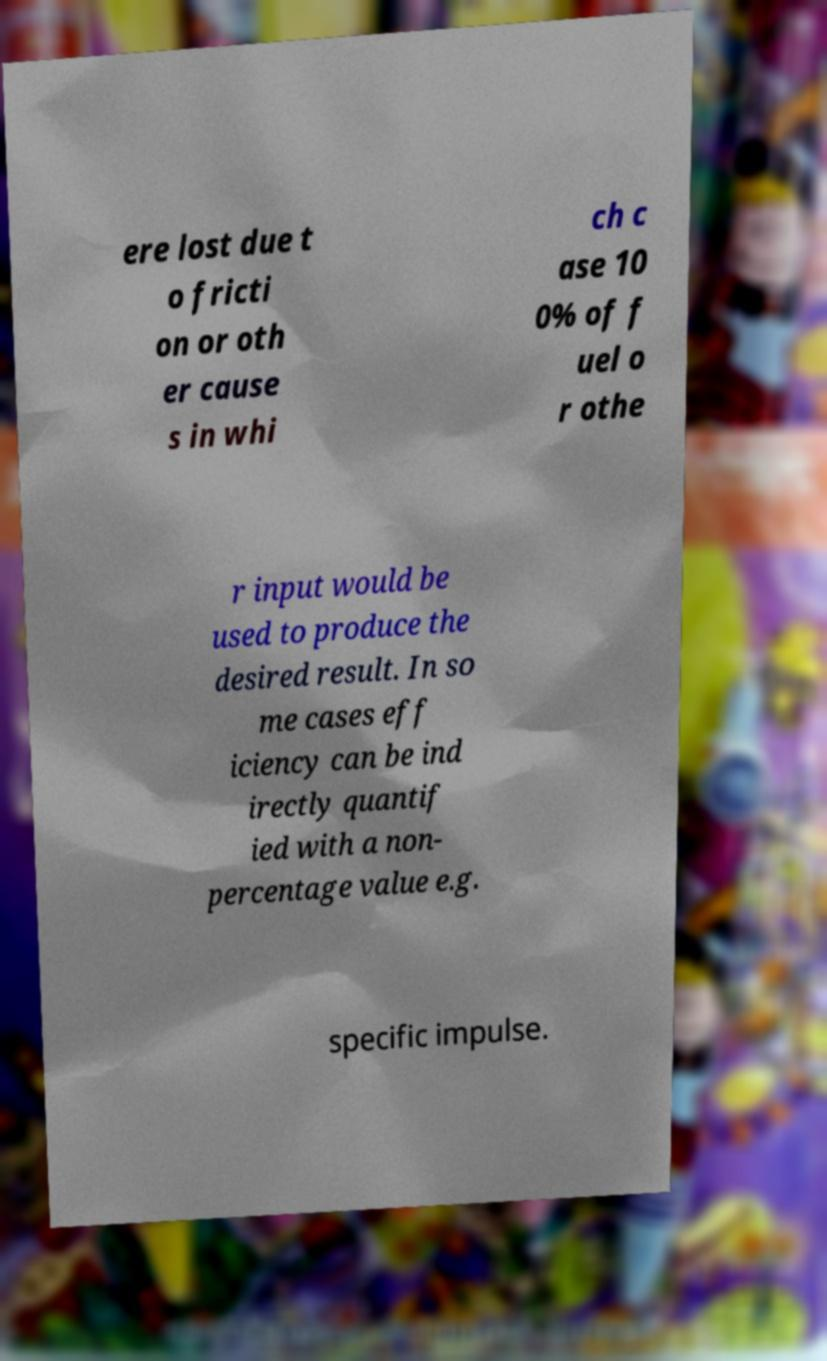Could you assist in decoding the text presented in this image and type it out clearly? ere lost due t o fricti on or oth er cause s in whi ch c ase 10 0% of f uel o r othe r input would be used to produce the desired result. In so me cases eff iciency can be ind irectly quantif ied with a non- percentage value e.g. specific impulse. 